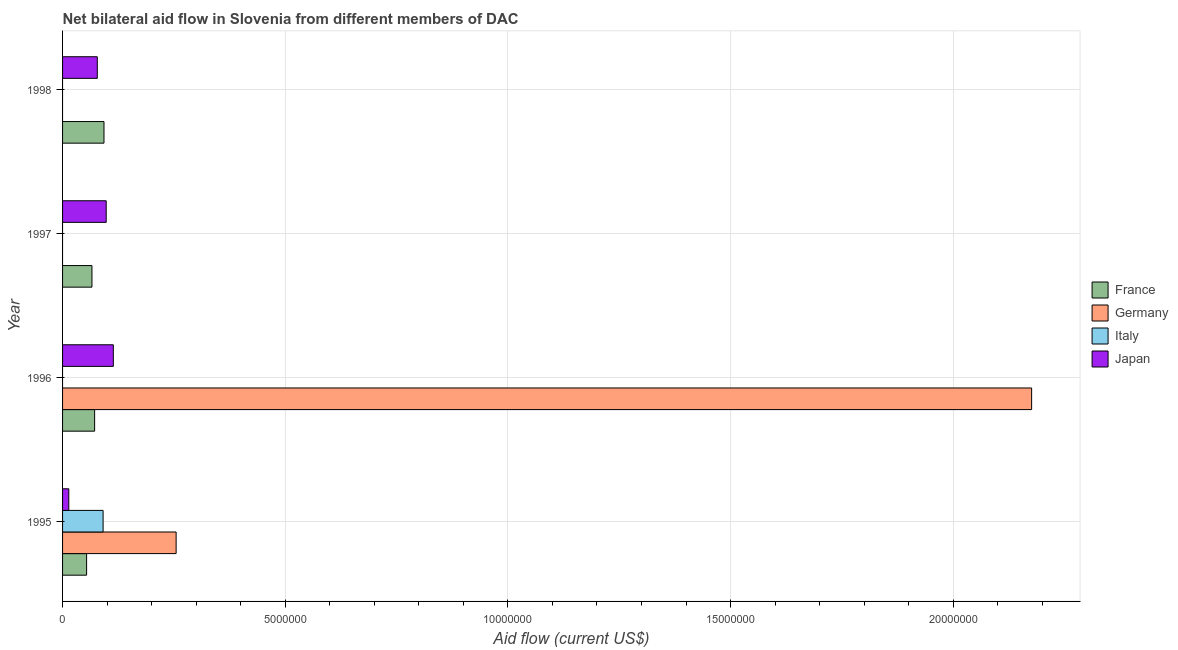Are the number of bars per tick equal to the number of legend labels?
Give a very brief answer. No. How many bars are there on the 3rd tick from the bottom?
Offer a very short reply. 2. What is the label of the 3rd group of bars from the top?
Provide a succinct answer. 1996. In how many cases, is the number of bars for a given year not equal to the number of legend labels?
Provide a short and direct response. 3. What is the amount of aid given by france in 1998?
Your answer should be compact. 9.30e+05. Across all years, what is the maximum amount of aid given by italy?
Keep it short and to the point. 9.10e+05. Across all years, what is the minimum amount of aid given by france?
Keep it short and to the point. 5.40e+05. What is the total amount of aid given by italy in the graph?
Offer a terse response. 9.10e+05. What is the difference between the amount of aid given by japan in 1996 and that in 1998?
Your answer should be compact. 3.60e+05. What is the difference between the amount of aid given by japan in 1995 and the amount of aid given by france in 1998?
Make the answer very short. -7.90e+05. What is the average amount of aid given by france per year?
Provide a short and direct response. 7.12e+05. In the year 1996, what is the difference between the amount of aid given by france and amount of aid given by japan?
Your answer should be compact. -4.20e+05. In how many years, is the amount of aid given by germany greater than 2000000 US$?
Provide a short and direct response. 2. What is the ratio of the amount of aid given by germany in 1995 to that in 1996?
Your answer should be compact. 0.12. Is the amount of aid given by germany in 1995 less than that in 1996?
Ensure brevity in your answer.  Yes. What is the difference between the highest and the lowest amount of aid given by france?
Offer a very short reply. 3.90e+05. Is it the case that in every year, the sum of the amount of aid given by france and amount of aid given by germany is greater than the sum of amount of aid given by japan and amount of aid given by italy?
Your answer should be very brief. No. Is it the case that in every year, the sum of the amount of aid given by france and amount of aid given by germany is greater than the amount of aid given by italy?
Offer a very short reply. Yes. How many bars are there?
Give a very brief answer. 11. Are all the bars in the graph horizontal?
Offer a very short reply. Yes. Are the values on the major ticks of X-axis written in scientific E-notation?
Offer a terse response. No. Where does the legend appear in the graph?
Your answer should be compact. Center right. How are the legend labels stacked?
Offer a terse response. Vertical. What is the title of the graph?
Keep it short and to the point. Net bilateral aid flow in Slovenia from different members of DAC. What is the label or title of the X-axis?
Keep it short and to the point. Aid flow (current US$). What is the label or title of the Y-axis?
Provide a succinct answer. Year. What is the Aid flow (current US$) of France in 1995?
Give a very brief answer. 5.40e+05. What is the Aid flow (current US$) in Germany in 1995?
Offer a very short reply. 2.55e+06. What is the Aid flow (current US$) in Italy in 1995?
Ensure brevity in your answer.  9.10e+05. What is the Aid flow (current US$) of France in 1996?
Your answer should be very brief. 7.20e+05. What is the Aid flow (current US$) of Germany in 1996?
Offer a very short reply. 2.18e+07. What is the Aid flow (current US$) in Japan in 1996?
Offer a very short reply. 1.14e+06. What is the Aid flow (current US$) in France in 1997?
Offer a very short reply. 6.60e+05. What is the Aid flow (current US$) in Germany in 1997?
Your answer should be compact. 0. What is the Aid flow (current US$) of Italy in 1997?
Your answer should be compact. 0. What is the Aid flow (current US$) in Japan in 1997?
Make the answer very short. 9.80e+05. What is the Aid flow (current US$) of France in 1998?
Offer a very short reply. 9.30e+05. What is the Aid flow (current US$) of Germany in 1998?
Provide a succinct answer. 0. What is the Aid flow (current US$) in Japan in 1998?
Your response must be concise. 7.80e+05. Across all years, what is the maximum Aid flow (current US$) of France?
Your answer should be compact. 9.30e+05. Across all years, what is the maximum Aid flow (current US$) of Germany?
Provide a succinct answer. 2.18e+07. Across all years, what is the maximum Aid flow (current US$) of Italy?
Offer a terse response. 9.10e+05. Across all years, what is the maximum Aid flow (current US$) of Japan?
Your answer should be compact. 1.14e+06. Across all years, what is the minimum Aid flow (current US$) in France?
Give a very brief answer. 5.40e+05. Across all years, what is the minimum Aid flow (current US$) of Germany?
Give a very brief answer. 0. Across all years, what is the minimum Aid flow (current US$) of Italy?
Provide a succinct answer. 0. Across all years, what is the minimum Aid flow (current US$) of Japan?
Your response must be concise. 1.40e+05. What is the total Aid flow (current US$) of France in the graph?
Your answer should be very brief. 2.85e+06. What is the total Aid flow (current US$) of Germany in the graph?
Provide a short and direct response. 2.43e+07. What is the total Aid flow (current US$) of Italy in the graph?
Provide a succinct answer. 9.10e+05. What is the total Aid flow (current US$) of Japan in the graph?
Make the answer very short. 3.04e+06. What is the difference between the Aid flow (current US$) of Germany in 1995 and that in 1996?
Offer a very short reply. -1.92e+07. What is the difference between the Aid flow (current US$) of Japan in 1995 and that in 1997?
Offer a terse response. -8.40e+05. What is the difference between the Aid flow (current US$) of France in 1995 and that in 1998?
Offer a very short reply. -3.90e+05. What is the difference between the Aid flow (current US$) in Japan in 1995 and that in 1998?
Provide a short and direct response. -6.40e+05. What is the difference between the Aid flow (current US$) of France in 1996 and that in 1997?
Ensure brevity in your answer.  6.00e+04. What is the difference between the Aid flow (current US$) in Japan in 1996 and that in 1997?
Offer a very short reply. 1.60e+05. What is the difference between the Aid flow (current US$) of France in 1996 and that in 1998?
Your answer should be very brief. -2.10e+05. What is the difference between the Aid flow (current US$) of France in 1997 and that in 1998?
Offer a terse response. -2.70e+05. What is the difference between the Aid flow (current US$) in France in 1995 and the Aid flow (current US$) in Germany in 1996?
Offer a terse response. -2.12e+07. What is the difference between the Aid flow (current US$) of France in 1995 and the Aid flow (current US$) of Japan in 1996?
Keep it short and to the point. -6.00e+05. What is the difference between the Aid flow (current US$) of Germany in 1995 and the Aid flow (current US$) of Japan in 1996?
Provide a short and direct response. 1.41e+06. What is the difference between the Aid flow (current US$) of France in 1995 and the Aid flow (current US$) of Japan in 1997?
Ensure brevity in your answer.  -4.40e+05. What is the difference between the Aid flow (current US$) in Germany in 1995 and the Aid flow (current US$) in Japan in 1997?
Ensure brevity in your answer.  1.57e+06. What is the difference between the Aid flow (current US$) in Germany in 1995 and the Aid flow (current US$) in Japan in 1998?
Offer a very short reply. 1.77e+06. What is the difference between the Aid flow (current US$) in Italy in 1995 and the Aid flow (current US$) in Japan in 1998?
Give a very brief answer. 1.30e+05. What is the difference between the Aid flow (current US$) in France in 1996 and the Aid flow (current US$) in Japan in 1997?
Offer a very short reply. -2.60e+05. What is the difference between the Aid flow (current US$) of Germany in 1996 and the Aid flow (current US$) of Japan in 1997?
Your response must be concise. 2.08e+07. What is the difference between the Aid flow (current US$) of France in 1996 and the Aid flow (current US$) of Japan in 1998?
Ensure brevity in your answer.  -6.00e+04. What is the difference between the Aid flow (current US$) in Germany in 1996 and the Aid flow (current US$) in Japan in 1998?
Offer a terse response. 2.10e+07. What is the average Aid flow (current US$) in France per year?
Provide a short and direct response. 7.12e+05. What is the average Aid flow (current US$) in Germany per year?
Your answer should be very brief. 6.08e+06. What is the average Aid flow (current US$) of Italy per year?
Provide a succinct answer. 2.28e+05. What is the average Aid flow (current US$) in Japan per year?
Offer a terse response. 7.60e+05. In the year 1995, what is the difference between the Aid flow (current US$) in France and Aid flow (current US$) in Germany?
Offer a terse response. -2.01e+06. In the year 1995, what is the difference between the Aid flow (current US$) in France and Aid flow (current US$) in Italy?
Keep it short and to the point. -3.70e+05. In the year 1995, what is the difference between the Aid flow (current US$) of Germany and Aid flow (current US$) of Italy?
Provide a short and direct response. 1.64e+06. In the year 1995, what is the difference between the Aid flow (current US$) of Germany and Aid flow (current US$) of Japan?
Offer a terse response. 2.41e+06. In the year 1995, what is the difference between the Aid flow (current US$) in Italy and Aid flow (current US$) in Japan?
Your answer should be very brief. 7.70e+05. In the year 1996, what is the difference between the Aid flow (current US$) in France and Aid flow (current US$) in Germany?
Your answer should be very brief. -2.10e+07. In the year 1996, what is the difference between the Aid flow (current US$) of France and Aid flow (current US$) of Japan?
Offer a very short reply. -4.20e+05. In the year 1996, what is the difference between the Aid flow (current US$) in Germany and Aid flow (current US$) in Japan?
Make the answer very short. 2.06e+07. In the year 1997, what is the difference between the Aid flow (current US$) in France and Aid flow (current US$) in Japan?
Offer a terse response. -3.20e+05. What is the ratio of the Aid flow (current US$) in France in 1995 to that in 1996?
Your answer should be compact. 0.75. What is the ratio of the Aid flow (current US$) of Germany in 1995 to that in 1996?
Provide a short and direct response. 0.12. What is the ratio of the Aid flow (current US$) of Japan in 1995 to that in 1996?
Provide a succinct answer. 0.12. What is the ratio of the Aid flow (current US$) of France in 1995 to that in 1997?
Your answer should be compact. 0.82. What is the ratio of the Aid flow (current US$) of Japan in 1995 to that in 1997?
Offer a very short reply. 0.14. What is the ratio of the Aid flow (current US$) in France in 1995 to that in 1998?
Make the answer very short. 0.58. What is the ratio of the Aid flow (current US$) of Japan in 1995 to that in 1998?
Ensure brevity in your answer.  0.18. What is the ratio of the Aid flow (current US$) of Japan in 1996 to that in 1997?
Your answer should be very brief. 1.16. What is the ratio of the Aid flow (current US$) in France in 1996 to that in 1998?
Offer a terse response. 0.77. What is the ratio of the Aid flow (current US$) in Japan in 1996 to that in 1998?
Your answer should be very brief. 1.46. What is the ratio of the Aid flow (current US$) in France in 1997 to that in 1998?
Your answer should be compact. 0.71. What is the ratio of the Aid flow (current US$) in Japan in 1997 to that in 1998?
Ensure brevity in your answer.  1.26. What is the difference between the highest and the lowest Aid flow (current US$) of France?
Keep it short and to the point. 3.90e+05. What is the difference between the highest and the lowest Aid flow (current US$) in Germany?
Offer a very short reply. 2.18e+07. What is the difference between the highest and the lowest Aid flow (current US$) of Italy?
Keep it short and to the point. 9.10e+05. 